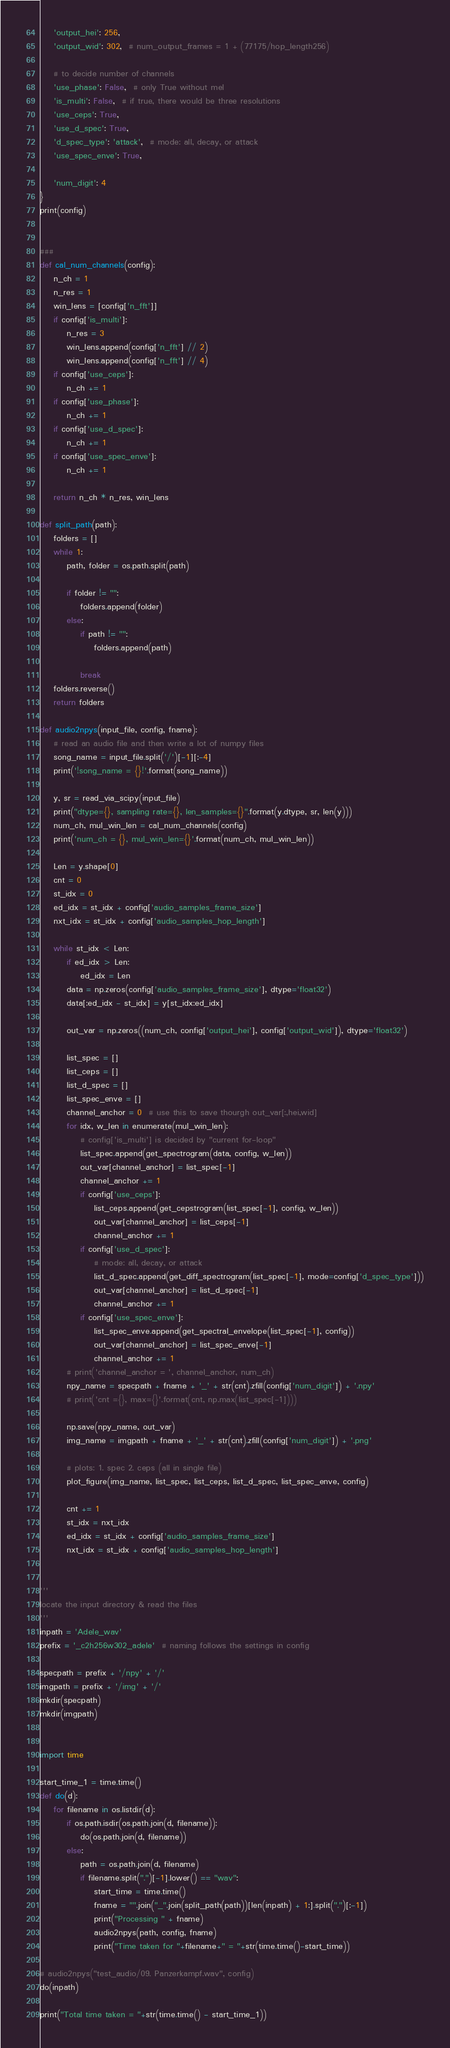<code> <loc_0><loc_0><loc_500><loc_500><_Python_>    'output_hei': 256,
    'output_wid': 302,  # num_output_frames = 1 + (77175/hop_length256)

    # to decide number of channels
    'use_phase': False,  # only True without mel
    'is_multi': False,  # if true, there would be three resolutions
    'use_ceps': True,
    'use_d_spec': True,
    'd_spec_type': 'attack',  # mode: all, decay, or attack
    'use_spec_enve': True,

    'num_digit': 4
}
print(config)


###
def cal_num_channels(config):
    n_ch = 1
    n_res = 1
    win_lens = [config['n_fft']]
    if config['is_multi']:
        n_res = 3
        win_lens.append(config['n_fft'] // 2)
        win_lens.append(config['n_fft'] // 4)
    if config['use_ceps']:
        n_ch += 1
    if config['use_phase']:
        n_ch += 1
    if config['use_d_spec']:
        n_ch += 1
    if config['use_spec_enve']:
        n_ch += 1

    return n_ch * n_res, win_lens

def split_path(path):
    folders = []
    while 1:
        path, folder = os.path.split(path)

        if folder != "":
            folders.append(folder)
        else:
            if path != "":
                folders.append(path)

            break
    folders.reverse()
    return folders

def audio2npys(input_file, config, fname):
    # read an audio file and then write a lot of numpy files
    song_name = input_file.split('/')[-1][:-4]
    print('!song_name = {}!'.format(song_name))

    y, sr = read_via_scipy(input_file)
    print("dtype={}, sampling rate={}, len_samples={}".format(y.dtype, sr, len(y)))
    num_ch, mul_win_len = cal_num_channels(config)
    print('num_ch = {}, mul_win_len={}'.format(num_ch, mul_win_len))

    Len = y.shape[0]
    cnt = 0
    st_idx = 0
    ed_idx = st_idx + config['audio_samples_frame_size']
    nxt_idx = st_idx + config['audio_samples_hop_length']

    while st_idx < Len:
        if ed_idx > Len:
            ed_idx = Len
        data = np.zeros(config['audio_samples_frame_size'], dtype='float32')
        data[:ed_idx - st_idx] = y[st_idx:ed_idx]

        out_var = np.zeros((num_ch, config['output_hei'], config['output_wid']), dtype='float32')

        list_spec = []
        list_ceps = []
        list_d_spec = []
        list_spec_enve = []
        channel_anchor = 0  # use this to save thourgh out_var[:,hei,wid]
        for idx, w_len in enumerate(mul_win_len):
            # config['is_multi'] is decided by "current for-loop"
            list_spec.append(get_spectrogram(data, config, w_len))
            out_var[channel_anchor] = list_spec[-1]
            channel_anchor += 1
            if config['use_ceps']:
                list_ceps.append(get_cepstrogram(list_spec[-1], config, w_len))
                out_var[channel_anchor] = list_ceps[-1]
                channel_anchor += 1
            if config['use_d_spec']:
                # mode: all, decay, or attack
                list_d_spec.append(get_diff_spectrogram(list_spec[-1], mode=config['d_spec_type']))
                out_var[channel_anchor] = list_d_spec[-1]
                channel_anchor += 1
            if config['use_spec_enve']:
                list_spec_enve.append(get_spectral_envelope(list_spec[-1], config))
                out_var[channel_anchor] = list_spec_enve[-1]
                channel_anchor += 1
        # print('channel_anchor = ', channel_anchor, num_ch)
        npy_name = specpath + fname + '_' + str(cnt).zfill(config['num_digit']) + '.npy'
        # print('cnt ={}, max={}'.format(cnt, np.max(list_spec[-1])))

        np.save(npy_name, out_var)
        img_name = imgpath + fname + '_' + str(cnt).zfill(config['num_digit']) + '.png'

        # plots: 1. spec 2. ceps (all in single file)
        plot_figure(img_name, list_spec, list_ceps, list_d_spec, list_spec_enve, config)

        cnt += 1
        st_idx = nxt_idx
        ed_idx = st_idx + config['audio_samples_frame_size']
        nxt_idx = st_idx + config['audio_samples_hop_length']


'''
locate the input directory & read the files
'''
inpath = 'Adele_wav'
prefix = '_c2h256w302_adele'  # naming follows the settings in config

specpath = prefix + '/npy' + '/'
imgpath = prefix + '/img' + '/'
mkdir(specpath)
mkdir(imgpath)


import time

start_time_1 = time.time()
def do(d):
    for filename in os.listdir(d):
        if os.path.isdir(os.path.join(d, filename)):
            do(os.path.join(d, filename))
        else:
            path = os.path.join(d, filename)
            if filename.split(".")[-1].lower() == "wav":
                start_time = time.time()
                fname = "".join("_".join(split_path(path))[len(inpath) + 1:].split(".")[:-1])
                print("Processing " + fname)
                audio2npys(path, config, fname)
                print("Time taken for "+filename+" = "+str(time.time()-start_time))

# audio2npys("test_audio/09. Panzerkampf.wav", config)
do(inpath)

print("Total time taken = "+str(time.time() - start_time_1))</code> 